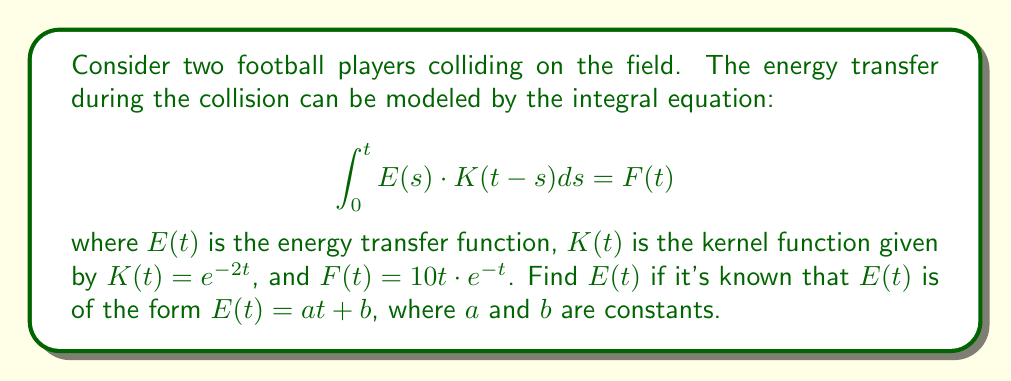Solve this math problem. Let's solve this step-by-step:

1) We're given that $E(t) = at + b$. Let's substitute this into the integral equation:

   $$\int_0^t (as + b) \cdot e^{-2(t-s)} ds = 10t \cdot e^{-t}$$

2) Let's evaluate the left-hand side of the equation:

   $$\int_0^t (as + b) \cdot e^{-2t} \cdot e^{2s} ds = 10t \cdot e^{-t}$$

   $$e^{-2t} \int_0^t (as + b) \cdot e^{2s} ds = 10t \cdot e^{-t}$$

3) Evaluate the integral:

   $$e^{-2t} \left[\frac{a}{4}e^{2s} - \frac{a}{2}se^{2s} + \frac{b}{2}e^{2s}\right]_0^t = 10t \cdot e^{-t}$$

4) Simplify:

   $$e^{-2t} \left[\frac{a}{4}e^{2t} - \frac{a}{2}te^{2t} + \frac{b}{2}e^{2t} - \frac{a}{4} - \frac{b}{2}\right] = 10t \cdot e^{-t}$$

   $$\frac{a}{4} - \frac{a}{2}t + \frac{b}{2} - \frac{a}{4}e^{-2t} - \frac{b}{2}e^{-2t} = 10t \cdot e^{-t}$$

5) For this equation to hold for all $t$, the coefficients of $t$ and the constant terms on both sides must be equal:

   Coefficient of $t$: $-\frac{a}{2} = 10e^{-t}$
   Constant term: $\frac{a}{4} + \frac{b}{2} = 0$

6) From the first equation: $a = -20e^{-t}$
   
   However, $a$ must be a constant, so this is only possible if $a = 0$.

7) If $a = 0$, then from the second equation: $b = 0$

Therefore, $E(t) = 0$.
Answer: $E(t) = 0$ 